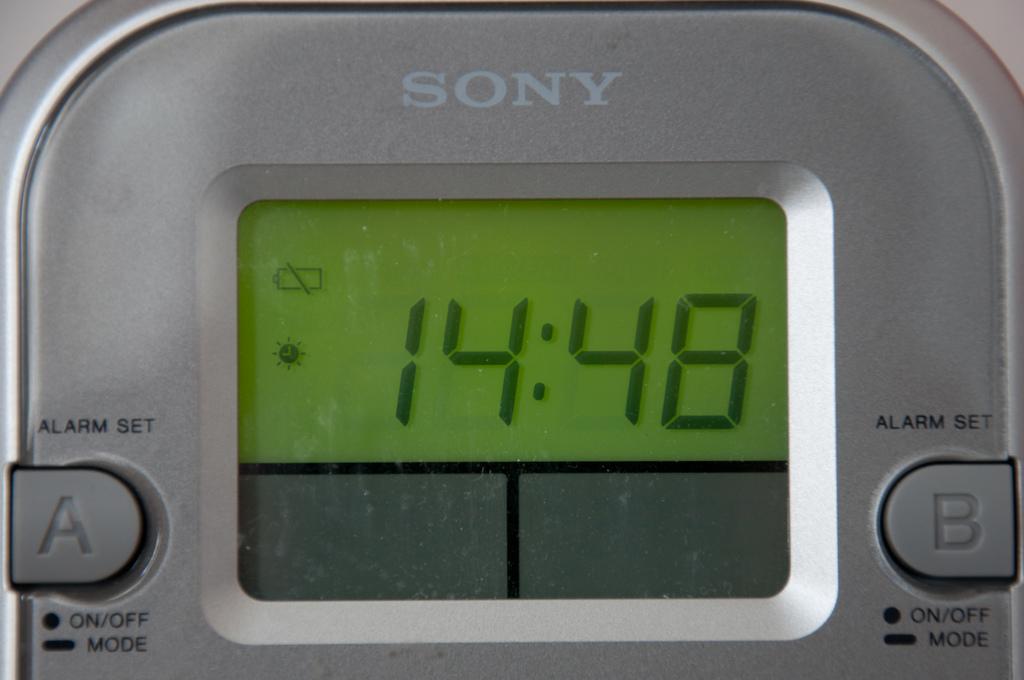What type of technology is that?
Your response must be concise. Answering does not require reading text in the image. What time does the device say?
Ensure brevity in your answer.  14:48. 